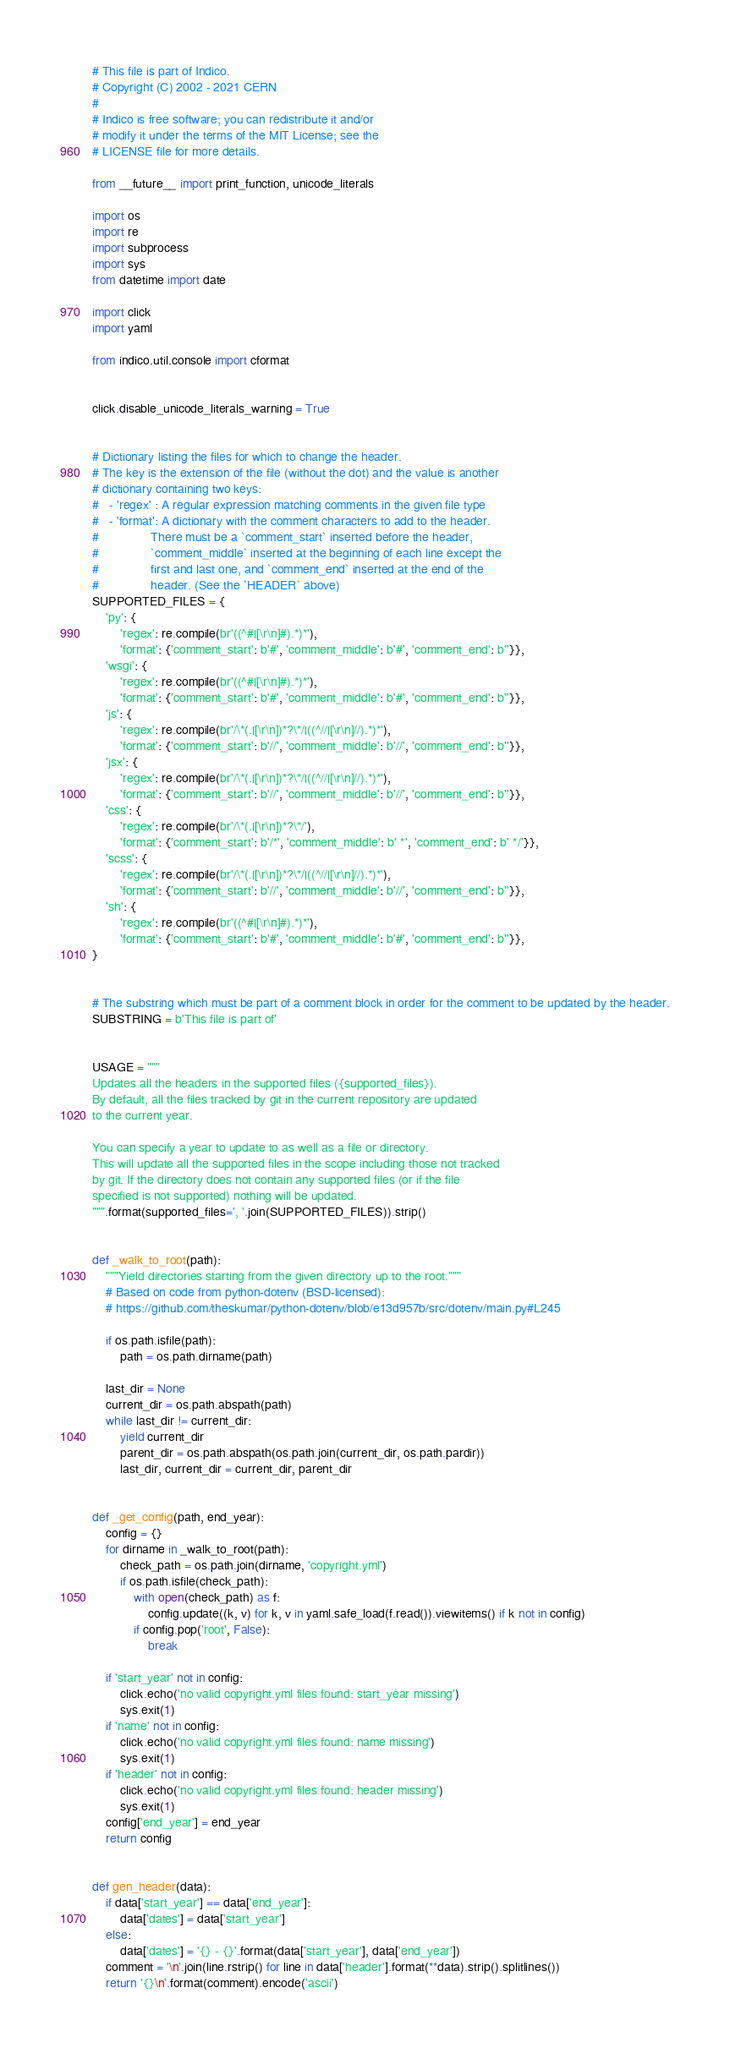Convert code to text. <code><loc_0><loc_0><loc_500><loc_500><_Python_># This file is part of Indico.
# Copyright (C) 2002 - 2021 CERN
#
# Indico is free software; you can redistribute it and/or
# modify it under the terms of the MIT License; see the
# LICENSE file for more details.

from __future__ import print_function, unicode_literals

import os
import re
import subprocess
import sys
from datetime import date

import click
import yaml

from indico.util.console import cformat


click.disable_unicode_literals_warning = True


# Dictionary listing the files for which to change the header.
# The key is the extension of the file (without the dot) and the value is another
# dictionary containing two keys:
#   - 'regex' : A regular expression matching comments in the given file type
#   - 'format': A dictionary with the comment characters to add to the header.
#               There must be a `comment_start` inserted before the header,
#               `comment_middle` inserted at the beginning of each line except the
#               first and last one, and `comment_end` inserted at the end of the
#               header. (See the `HEADER` above)
SUPPORTED_FILES = {
    'py': {
        'regex': re.compile(br'((^#|[\r\n]#).*)*'),
        'format': {'comment_start': b'#', 'comment_middle': b'#', 'comment_end': b''}},
    'wsgi': {
        'regex': re.compile(br'((^#|[\r\n]#).*)*'),
        'format': {'comment_start': b'#', 'comment_middle': b'#', 'comment_end': b''}},
    'js': {
        'regex': re.compile(br'/\*(.|[\r\n])*?\*/|((^//|[\r\n]//).*)*'),
        'format': {'comment_start': b'//', 'comment_middle': b'//', 'comment_end': b''}},
    'jsx': {
        'regex': re.compile(br'/\*(.|[\r\n])*?\*/|((^//|[\r\n]//).*)*'),
        'format': {'comment_start': b'//', 'comment_middle': b'//', 'comment_end': b''}},
    'css': {
        'regex': re.compile(br'/\*(.|[\r\n])*?\*/'),
        'format': {'comment_start': b'/*', 'comment_middle': b' *', 'comment_end': b' */'}},
    'scss': {
        'regex': re.compile(br'/\*(.|[\r\n])*?\*/|((^//|[\r\n]//).*)*'),
        'format': {'comment_start': b'//', 'comment_middle': b'//', 'comment_end': b''}},
    'sh': {
        'regex': re.compile(br'((^#|[\r\n]#).*)*'),
        'format': {'comment_start': b'#', 'comment_middle': b'#', 'comment_end': b''}},
}


# The substring which must be part of a comment block in order for the comment to be updated by the header.
SUBSTRING = b'This file is part of'


USAGE = """
Updates all the headers in the supported files ({supported_files}).
By default, all the files tracked by git in the current repository are updated
to the current year.

You can specify a year to update to as well as a file or directory.
This will update all the supported files in the scope including those not tracked
by git. If the directory does not contain any supported files (or if the file
specified is not supported) nothing will be updated.
""".format(supported_files=', '.join(SUPPORTED_FILES)).strip()


def _walk_to_root(path):
    """Yield directories starting from the given directory up to the root."""
    # Based on code from python-dotenv (BSD-licensed):
    # https://github.com/theskumar/python-dotenv/blob/e13d957b/src/dotenv/main.py#L245

    if os.path.isfile(path):
        path = os.path.dirname(path)

    last_dir = None
    current_dir = os.path.abspath(path)
    while last_dir != current_dir:
        yield current_dir
        parent_dir = os.path.abspath(os.path.join(current_dir, os.path.pardir))
        last_dir, current_dir = current_dir, parent_dir


def _get_config(path, end_year):
    config = {}
    for dirname in _walk_to_root(path):
        check_path = os.path.join(dirname, 'copyright.yml')
        if os.path.isfile(check_path):
            with open(check_path) as f:
                config.update((k, v) for k, v in yaml.safe_load(f.read()).viewitems() if k not in config)
            if config.pop('root', False):
                break

    if 'start_year' not in config:
        click.echo('no valid copyright.yml files found: start_year missing')
        sys.exit(1)
    if 'name' not in config:
        click.echo('no valid copyright.yml files found: name missing')
        sys.exit(1)
    if 'header' not in config:
        click.echo('no valid copyright.yml files found: header missing')
        sys.exit(1)
    config['end_year'] = end_year
    return config


def gen_header(data):
    if data['start_year'] == data['end_year']:
        data['dates'] = data['start_year']
    else:
        data['dates'] = '{} - {}'.format(data['start_year'], data['end_year'])
    comment = '\n'.join(line.rstrip() for line in data['header'].format(**data).strip().splitlines())
    return '{}\n'.format(comment).encode('ascii')

</code> 